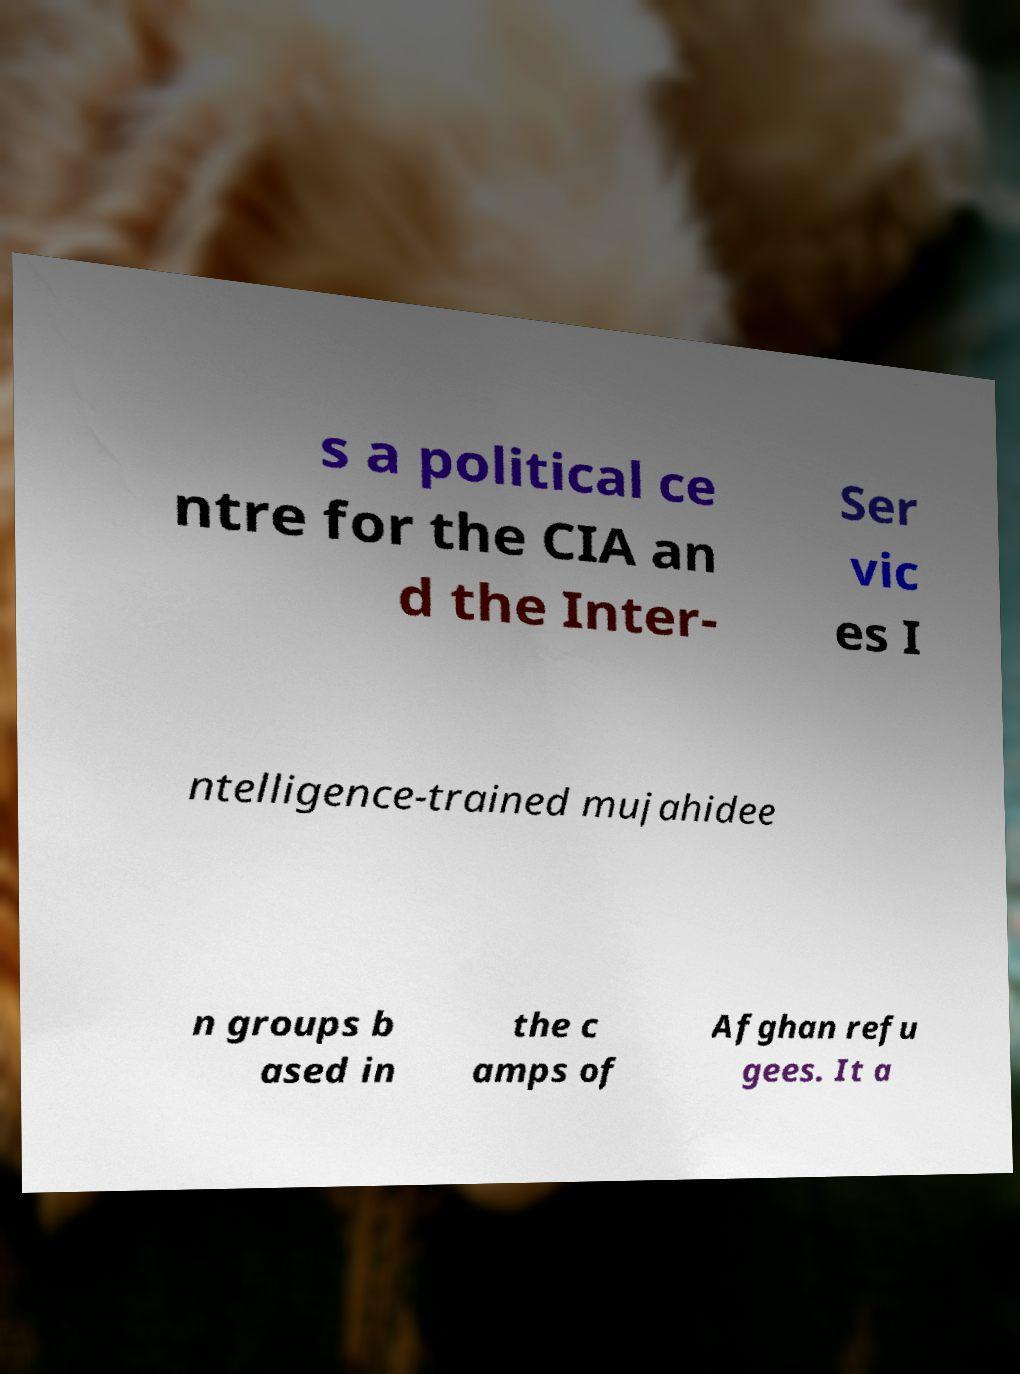Can you accurately transcribe the text from the provided image for me? s a political ce ntre for the CIA an d the Inter- Ser vic es I ntelligence-trained mujahidee n groups b ased in the c amps of Afghan refu gees. It a 